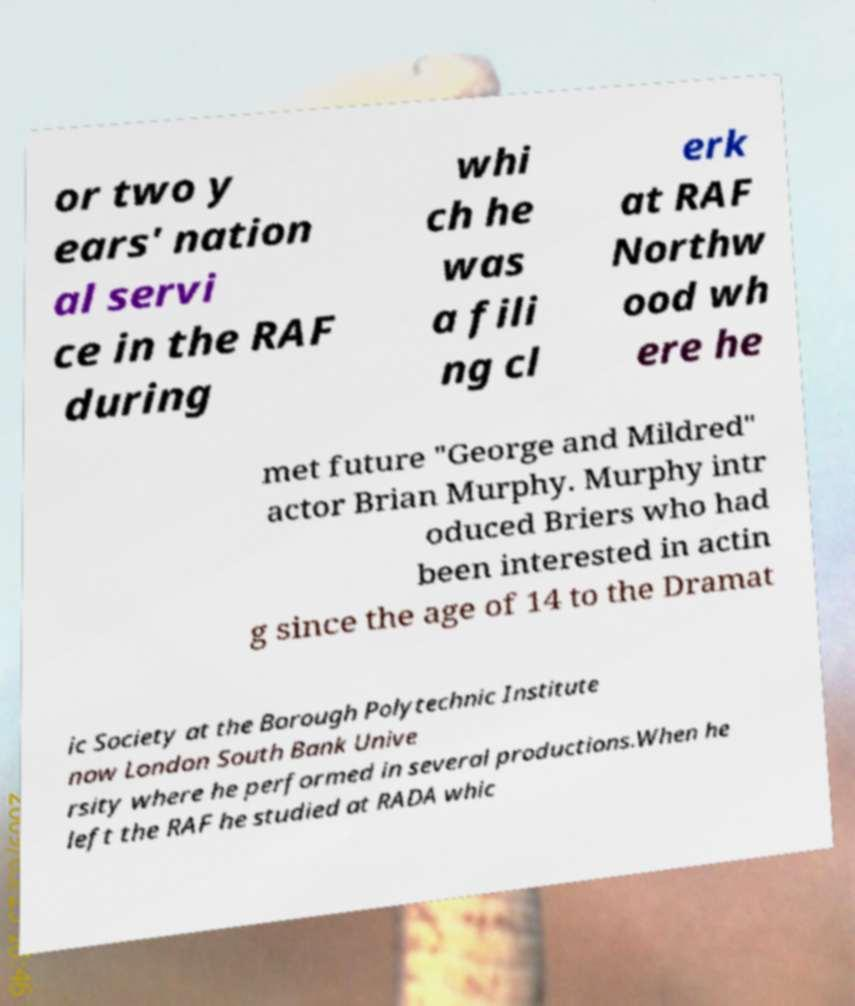What messages or text are displayed in this image? I need them in a readable, typed format. or two y ears' nation al servi ce in the RAF during whi ch he was a fili ng cl erk at RAF Northw ood wh ere he met future "George and Mildred" actor Brian Murphy. Murphy intr oduced Briers who had been interested in actin g since the age of 14 to the Dramat ic Society at the Borough Polytechnic Institute now London South Bank Unive rsity where he performed in several productions.When he left the RAF he studied at RADA whic 